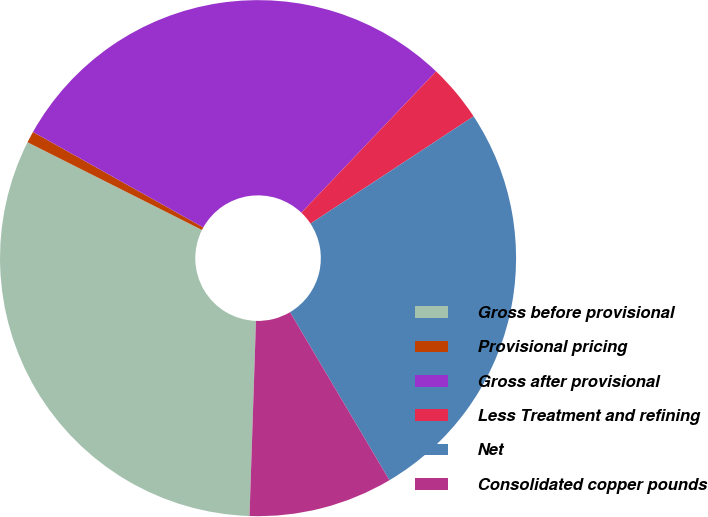Convert chart to OTSL. <chart><loc_0><loc_0><loc_500><loc_500><pie_chart><fcel>Gross before provisional<fcel>Provisional pricing<fcel>Gross after provisional<fcel>Less Treatment and refining<fcel>Net<fcel>Consolidated copper pounds<nl><fcel>31.89%<fcel>0.72%<fcel>28.99%<fcel>3.62%<fcel>25.76%<fcel>9.03%<nl></chart> 